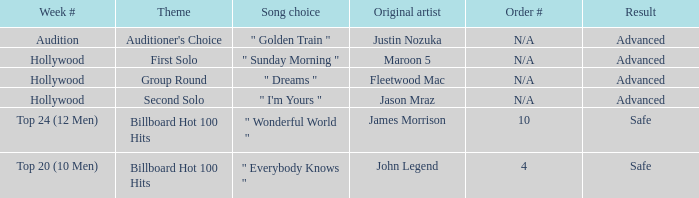What are all of the order # where authentic artist is maroon 5 N/A. 